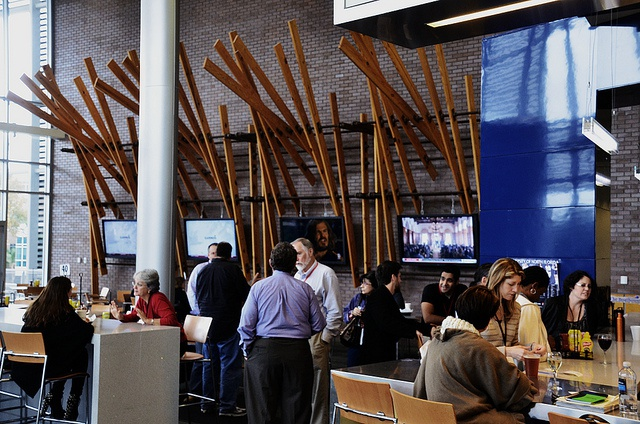Describe the objects in this image and their specific colors. I can see people in lightgray, black, gray, darkgray, and purple tones, people in lightgray, black, maroon, and gray tones, people in lightgray, black, navy, gray, and blue tones, people in lightgray, black, gray, and darkblue tones, and people in lightgray, black, gray, and darkgray tones in this image. 